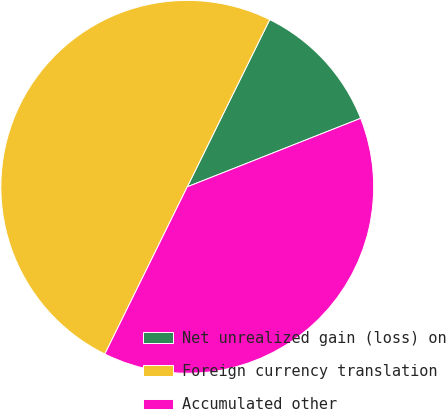<chart> <loc_0><loc_0><loc_500><loc_500><pie_chart><fcel>Net unrealized gain (loss) on<fcel>Foreign currency translation<fcel>Accumulated other<nl><fcel>11.72%<fcel>50.0%<fcel>38.28%<nl></chart> 